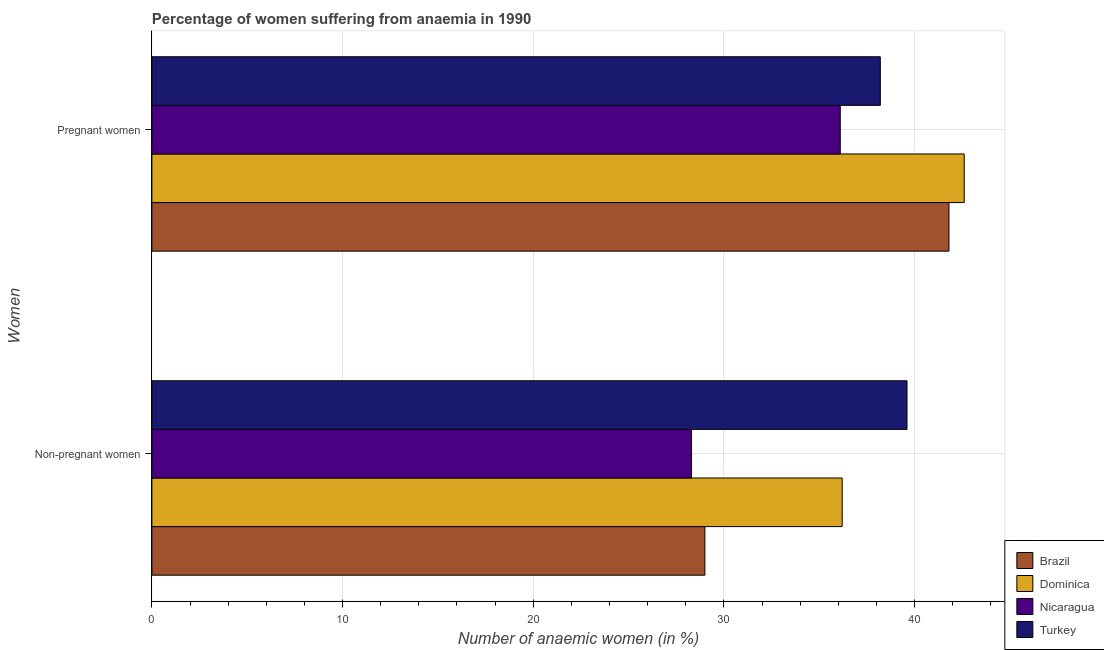How many groups of bars are there?
Provide a succinct answer. 2. Are the number of bars per tick equal to the number of legend labels?
Keep it short and to the point. Yes. How many bars are there on the 2nd tick from the top?
Provide a short and direct response. 4. What is the label of the 2nd group of bars from the top?
Keep it short and to the point. Non-pregnant women. What is the percentage of non-pregnant anaemic women in Turkey?
Your answer should be compact. 39.6. Across all countries, what is the maximum percentage of non-pregnant anaemic women?
Provide a short and direct response. 39.6. Across all countries, what is the minimum percentage of pregnant anaemic women?
Your answer should be very brief. 36.1. In which country was the percentage of non-pregnant anaemic women maximum?
Offer a terse response. Turkey. In which country was the percentage of pregnant anaemic women minimum?
Provide a succinct answer. Nicaragua. What is the total percentage of non-pregnant anaemic women in the graph?
Your answer should be compact. 133.1. What is the difference between the percentage of pregnant anaemic women in Nicaragua and that in Turkey?
Ensure brevity in your answer.  -2.1. What is the difference between the percentage of non-pregnant anaemic women in Nicaragua and the percentage of pregnant anaemic women in Dominica?
Make the answer very short. -14.3. What is the average percentage of pregnant anaemic women per country?
Your answer should be very brief. 39.67. What is the difference between the percentage of pregnant anaemic women and percentage of non-pregnant anaemic women in Dominica?
Provide a succinct answer. 6.4. In how many countries, is the percentage of pregnant anaemic women greater than 42 %?
Your response must be concise. 1. What is the ratio of the percentage of non-pregnant anaemic women in Dominica to that in Brazil?
Your response must be concise. 1.25. What does the 1st bar from the top in Pregnant women represents?
Keep it short and to the point. Turkey. What does the 2nd bar from the bottom in Non-pregnant women represents?
Offer a very short reply. Dominica. Are all the bars in the graph horizontal?
Offer a very short reply. Yes. How many countries are there in the graph?
Keep it short and to the point. 4. What is the difference between two consecutive major ticks on the X-axis?
Your answer should be very brief. 10. Does the graph contain any zero values?
Give a very brief answer. No. Does the graph contain grids?
Give a very brief answer. Yes. Where does the legend appear in the graph?
Provide a short and direct response. Bottom right. How are the legend labels stacked?
Your answer should be very brief. Vertical. What is the title of the graph?
Your answer should be compact. Percentage of women suffering from anaemia in 1990. Does "Isle of Man" appear as one of the legend labels in the graph?
Ensure brevity in your answer.  No. What is the label or title of the X-axis?
Your response must be concise. Number of anaemic women (in %). What is the label or title of the Y-axis?
Your answer should be very brief. Women. What is the Number of anaemic women (in %) in Dominica in Non-pregnant women?
Offer a very short reply. 36.2. What is the Number of anaemic women (in %) in Nicaragua in Non-pregnant women?
Your response must be concise. 28.3. What is the Number of anaemic women (in %) in Turkey in Non-pregnant women?
Make the answer very short. 39.6. What is the Number of anaemic women (in %) of Brazil in Pregnant women?
Your answer should be compact. 41.8. What is the Number of anaemic women (in %) of Dominica in Pregnant women?
Offer a very short reply. 42.6. What is the Number of anaemic women (in %) of Nicaragua in Pregnant women?
Provide a short and direct response. 36.1. What is the Number of anaemic women (in %) in Turkey in Pregnant women?
Your response must be concise. 38.2. Across all Women, what is the maximum Number of anaemic women (in %) in Brazil?
Give a very brief answer. 41.8. Across all Women, what is the maximum Number of anaemic women (in %) of Dominica?
Ensure brevity in your answer.  42.6. Across all Women, what is the maximum Number of anaemic women (in %) in Nicaragua?
Your answer should be very brief. 36.1. Across all Women, what is the maximum Number of anaemic women (in %) in Turkey?
Your answer should be compact. 39.6. Across all Women, what is the minimum Number of anaemic women (in %) in Brazil?
Keep it short and to the point. 29. Across all Women, what is the minimum Number of anaemic women (in %) in Dominica?
Your response must be concise. 36.2. Across all Women, what is the minimum Number of anaemic women (in %) of Nicaragua?
Keep it short and to the point. 28.3. Across all Women, what is the minimum Number of anaemic women (in %) of Turkey?
Your answer should be compact. 38.2. What is the total Number of anaemic women (in %) in Brazil in the graph?
Ensure brevity in your answer.  70.8. What is the total Number of anaemic women (in %) of Dominica in the graph?
Offer a terse response. 78.8. What is the total Number of anaemic women (in %) in Nicaragua in the graph?
Your answer should be very brief. 64.4. What is the total Number of anaemic women (in %) in Turkey in the graph?
Provide a short and direct response. 77.8. What is the difference between the Number of anaemic women (in %) of Brazil in Non-pregnant women and that in Pregnant women?
Offer a terse response. -12.8. What is the difference between the Number of anaemic women (in %) of Dominica in Non-pregnant women and that in Pregnant women?
Provide a succinct answer. -6.4. What is the difference between the Number of anaemic women (in %) of Brazil in Non-pregnant women and the Number of anaemic women (in %) of Nicaragua in Pregnant women?
Keep it short and to the point. -7.1. What is the difference between the Number of anaemic women (in %) in Dominica in Non-pregnant women and the Number of anaemic women (in %) in Nicaragua in Pregnant women?
Provide a short and direct response. 0.1. What is the average Number of anaemic women (in %) in Brazil per Women?
Ensure brevity in your answer.  35.4. What is the average Number of anaemic women (in %) in Dominica per Women?
Offer a terse response. 39.4. What is the average Number of anaemic women (in %) of Nicaragua per Women?
Offer a very short reply. 32.2. What is the average Number of anaemic women (in %) of Turkey per Women?
Your response must be concise. 38.9. What is the difference between the Number of anaemic women (in %) of Brazil and Number of anaemic women (in %) of Nicaragua in Pregnant women?
Your answer should be compact. 5.7. What is the difference between the Number of anaemic women (in %) of Dominica and Number of anaemic women (in %) of Turkey in Pregnant women?
Offer a very short reply. 4.4. What is the difference between the Number of anaemic women (in %) in Nicaragua and Number of anaemic women (in %) in Turkey in Pregnant women?
Ensure brevity in your answer.  -2.1. What is the ratio of the Number of anaemic women (in %) of Brazil in Non-pregnant women to that in Pregnant women?
Offer a very short reply. 0.69. What is the ratio of the Number of anaemic women (in %) of Dominica in Non-pregnant women to that in Pregnant women?
Keep it short and to the point. 0.85. What is the ratio of the Number of anaemic women (in %) of Nicaragua in Non-pregnant women to that in Pregnant women?
Ensure brevity in your answer.  0.78. What is the ratio of the Number of anaemic women (in %) of Turkey in Non-pregnant women to that in Pregnant women?
Offer a very short reply. 1.04. What is the difference between the highest and the second highest Number of anaemic women (in %) in Nicaragua?
Your answer should be very brief. 7.8. What is the difference between the highest and the lowest Number of anaemic women (in %) of Brazil?
Make the answer very short. 12.8. What is the difference between the highest and the lowest Number of anaemic women (in %) in Dominica?
Provide a succinct answer. 6.4. What is the difference between the highest and the lowest Number of anaemic women (in %) in Nicaragua?
Provide a succinct answer. 7.8. 